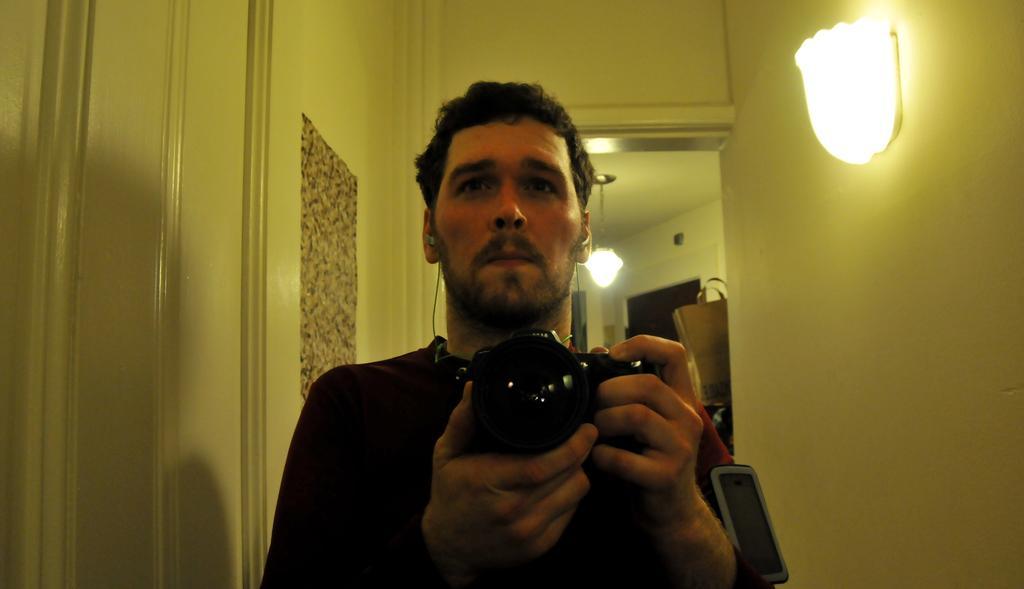In one or two sentences, can you explain what this image depicts? in this picture a man is holding a camera standing inside the building. In the right side on the wall there is a light. Behind the person there is a chandelier hangs from the ceiling. 